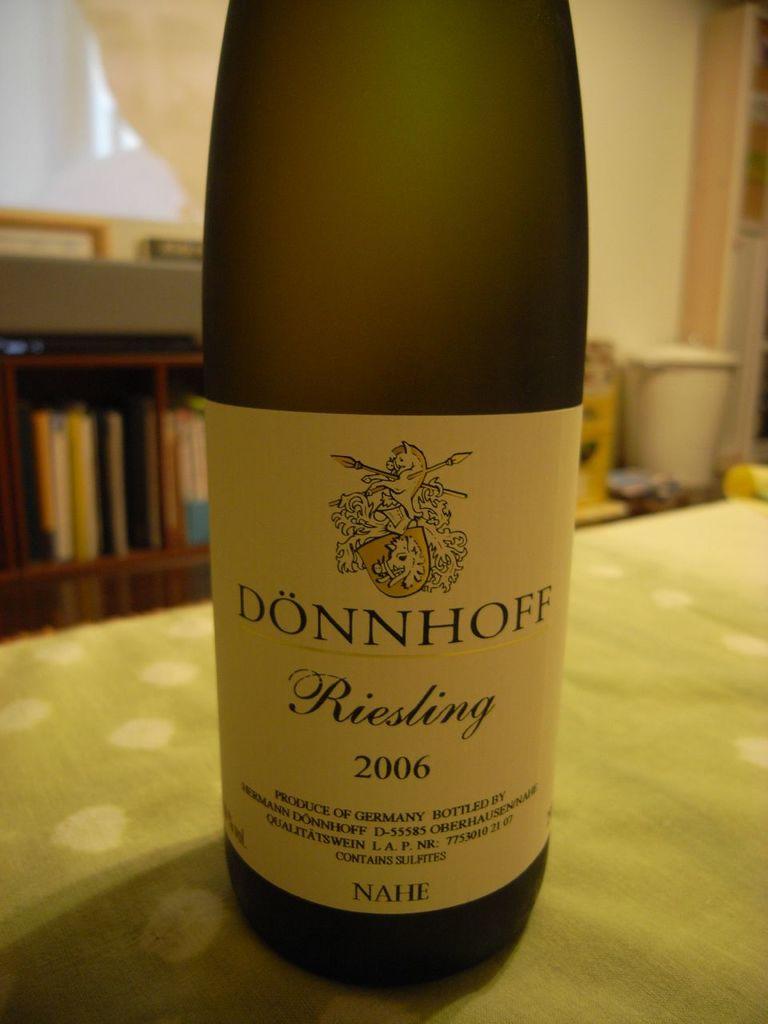What year is this bottle from?
Offer a very short reply. 2006. What year was the wine bottled?
Give a very brief answer. 2006. 